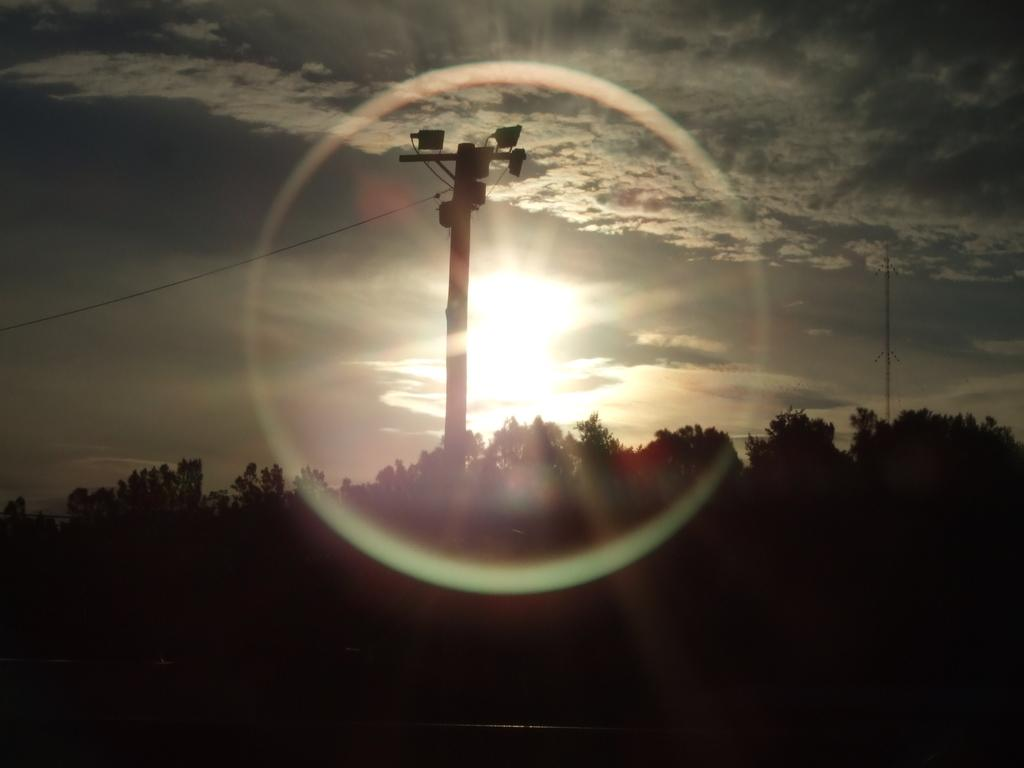What type of natural elements are present in the image? There are many trees and plants in the image. What can be seen in the middle of the image? There is a pole with lights in the middle of the image. What is visible in the background of the image? The sky is visible in the background of the image. What can be observed about the sky in the image? There are clouds in the sky, and the sun is visible in the sky. What type of house can be seen in the image? There is no house present in the image. 